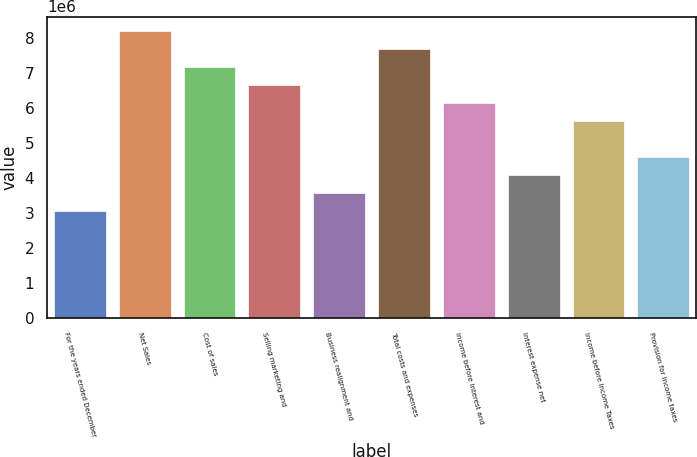<chart> <loc_0><loc_0><loc_500><loc_500><bar_chart><fcel>For the years ended December<fcel>Net Sales<fcel>Cost of sales<fcel>Selling marketing and<fcel>Business realignment and<fcel>Total costs and expenses<fcel>Income before Interest and<fcel>Interest expense net<fcel>Income before Income Taxes<fcel>Provision for income taxes<nl><fcel>3.07966e+06<fcel>8.21243e+06<fcel>7.18587e+06<fcel>6.6726e+06<fcel>3.59294e+06<fcel>7.69915e+06<fcel>6.15932e+06<fcel>4.10621e+06<fcel>5.64604e+06<fcel>4.61949e+06<nl></chart> 